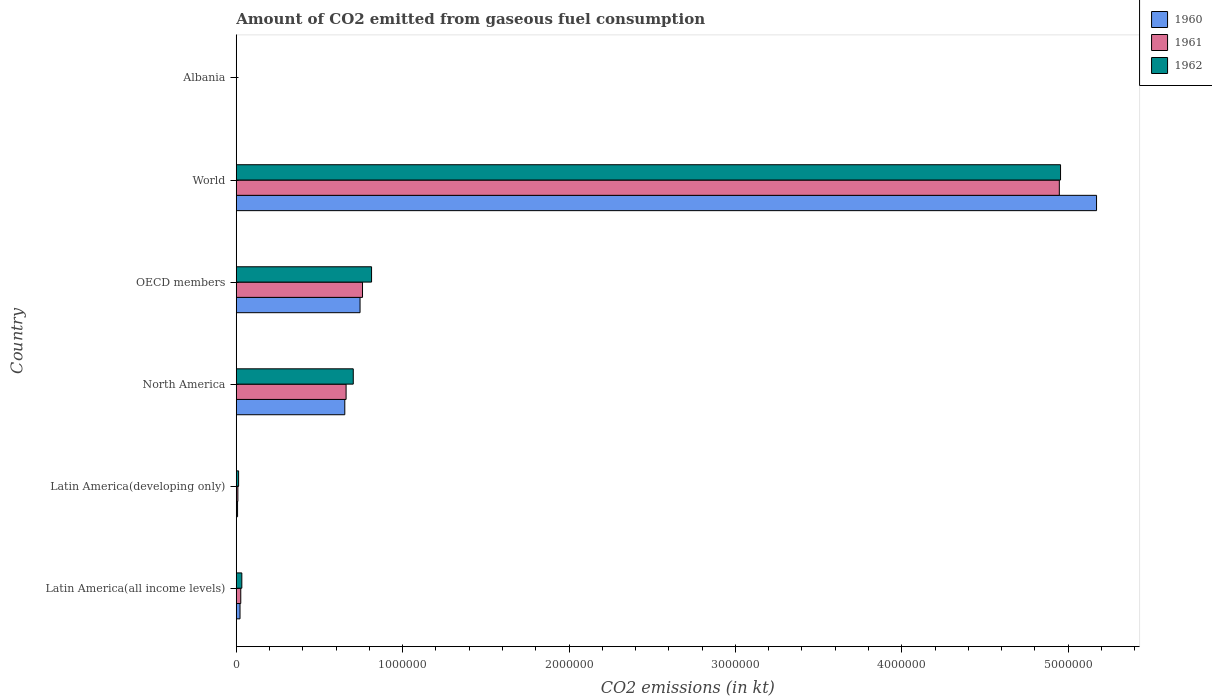How many different coloured bars are there?
Offer a very short reply. 3. How many bars are there on the 5th tick from the top?
Provide a succinct answer. 3. What is the label of the 6th group of bars from the top?
Make the answer very short. Latin America(all income levels). In how many cases, is the number of bars for a given country not equal to the number of legend labels?
Provide a short and direct response. 0. What is the amount of CO2 emitted in 1960 in World?
Give a very brief answer. 5.17e+06. Across all countries, what is the maximum amount of CO2 emitted in 1962?
Provide a short and direct response. 4.95e+06. Across all countries, what is the minimum amount of CO2 emitted in 1961?
Make the answer very short. 84.34. In which country was the amount of CO2 emitted in 1962 maximum?
Make the answer very short. World. In which country was the amount of CO2 emitted in 1961 minimum?
Keep it short and to the point. Albania. What is the total amount of CO2 emitted in 1961 in the graph?
Give a very brief answer. 6.40e+06. What is the difference between the amount of CO2 emitted in 1960 in Albania and that in Latin America(all income levels)?
Offer a terse response. -2.25e+04. What is the difference between the amount of CO2 emitted in 1961 in Albania and the amount of CO2 emitted in 1960 in OECD members?
Your response must be concise. -7.44e+05. What is the average amount of CO2 emitted in 1960 per country?
Offer a terse response. 1.10e+06. What is the difference between the amount of CO2 emitted in 1960 and amount of CO2 emitted in 1961 in OECD members?
Provide a short and direct response. -1.48e+04. What is the ratio of the amount of CO2 emitted in 1961 in Latin America(all income levels) to that in North America?
Give a very brief answer. 0.04. What is the difference between the highest and the second highest amount of CO2 emitted in 1960?
Offer a terse response. 4.43e+06. What is the difference between the highest and the lowest amount of CO2 emitted in 1961?
Offer a very short reply. 4.95e+06. In how many countries, is the amount of CO2 emitted in 1960 greater than the average amount of CO2 emitted in 1960 taken over all countries?
Ensure brevity in your answer.  1. Is the sum of the amount of CO2 emitted in 1962 in Latin America(all income levels) and World greater than the maximum amount of CO2 emitted in 1960 across all countries?
Provide a short and direct response. No. What does the 2nd bar from the top in OECD members represents?
Make the answer very short. 1961. What does the 3rd bar from the bottom in World represents?
Your response must be concise. 1962. How many bars are there?
Your answer should be compact. 18. Are all the bars in the graph horizontal?
Your response must be concise. Yes. Are the values on the major ticks of X-axis written in scientific E-notation?
Your answer should be very brief. No. Does the graph contain grids?
Your response must be concise. No. How many legend labels are there?
Keep it short and to the point. 3. How are the legend labels stacked?
Your answer should be compact. Vertical. What is the title of the graph?
Ensure brevity in your answer.  Amount of CO2 emitted from gaseous fuel consumption. Does "1987" appear as one of the legend labels in the graph?
Offer a very short reply. No. What is the label or title of the X-axis?
Offer a terse response. CO2 emissions (in kt). What is the label or title of the Y-axis?
Give a very brief answer. Country. What is the CO2 emissions (in kt) of 1960 in Latin America(all income levels)?
Your answer should be compact. 2.26e+04. What is the CO2 emissions (in kt) of 1961 in Latin America(all income levels)?
Your answer should be very brief. 2.71e+04. What is the CO2 emissions (in kt) of 1962 in Latin America(all income levels)?
Your response must be concise. 3.35e+04. What is the CO2 emissions (in kt) of 1960 in Latin America(developing only)?
Provide a succinct answer. 7838.55. What is the CO2 emissions (in kt) in 1961 in Latin America(developing only)?
Offer a terse response. 9714.77. What is the CO2 emissions (in kt) of 1962 in Latin America(developing only)?
Provide a short and direct response. 1.42e+04. What is the CO2 emissions (in kt) in 1960 in North America?
Offer a terse response. 6.52e+05. What is the CO2 emissions (in kt) in 1961 in North America?
Keep it short and to the point. 6.60e+05. What is the CO2 emissions (in kt) in 1962 in North America?
Provide a succinct answer. 7.03e+05. What is the CO2 emissions (in kt) in 1960 in OECD members?
Your response must be concise. 7.44e+05. What is the CO2 emissions (in kt) in 1961 in OECD members?
Offer a very short reply. 7.59e+05. What is the CO2 emissions (in kt) of 1962 in OECD members?
Your response must be concise. 8.13e+05. What is the CO2 emissions (in kt) in 1960 in World?
Offer a very short reply. 5.17e+06. What is the CO2 emissions (in kt) of 1961 in World?
Your answer should be very brief. 4.95e+06. What is the CO2 emissions (in kt) in 1962 in World?
Keep it short and to the point. 4.95e+06. What is the CO2 emissions (in kt) of 1960 in Albania?
Your answer should be very brief. 84.34. What is the CO2 emissions (in kt) in 1961 in Albania?
Offer a terse response. 84.34. What is the CO2 emissions (in kt) of 1962 in Albania?
Ensure brevity in your answer.  84.34. Across all countries, what is the maximum CO2 emissions (in kt) in 1960?
Provide a short and direct response. 5.17e+06. Across all countries, what is the maximum CO2 emissions (in kt) in 1961?
Your answer should be very brief. 4.95e+06. Across all countries, what is the maximum CO2 emissions (in kt) in 1962?
Offer a very short reply. 4.95e+06. Across all countries, what is the minimum CO2 emissions (in kt) of 1960?
Your answer should be very brief. 84.34. Across all countries, what is the minimum CO2 emissions (in kt) in 1961?
Offer a very short reply. 84.34. Across all countries, what is the minimum CO2 emissions (in kt) of 1962?
Give a very brief answer. 84.34. What is the total CO2 emissions (in kt) of 1960 in the graph?
Provide a succinct answer. 6.60e+06. What is the total CO2 emissions (in kt) of 1961 in the graph?
Ensure brevity in your answer.  6.40e+06. What is the total CO2 emissions (in kt) of 1962 in the graph?
Provide a short and direct response. 6.52e+06. What is the difference between the CO2 emissions (in kt) in 1960 in Latin America(all income levels) and that in Latin America(developing only)?
Keep it short and to the point. 1.47e+04. What is the difference between the CO2 emissions (in kt) in 1961 in Latin America(all income levels) and that in Latin America(developing only)?
Give a very brief answer. 1.74e+04. What is the difference between the CO2 emissions (in kt) of 1962 in Latin America(all income levels) and that in Latin America(developing only)?
Your response must be concise. 1.93e+04. What is the difference between the CO2 emissions (in kt) of 1960 in Latin America(all income levels) and that in North America?
Make the answer very short. -6.30e+05. What is the difference between the CO2 emissions (in kt) of 1961 in Latin America(all income levels) and that in North America?
Provide a short and direct response. -6.33e+05. What is the difference between the CO2 emissions (in kt) of 1962 in Latin America(all income levels) and that in North America?
Make the answer very short. -6.70e+05. What is the difference between the CO2 emissions (in kt) in 1960 in Latin America(all income levels) and that in OECD members?
Offer a terse response. -7.21e+05. What is the difference between the CO2 emissions (in kt) of 1961 in Latin America(all income levels) and that in OECD members?
Give a very brief answer. -7.32e+05. What is the difference between the CO2 emissions (in kt) of 1962 in Latin America(all income levels) and that in OECD members?
Give a very brief answer. -7.80e+05. What is the difference between the CO2 emissions (in kt) of 1960 in Latin America(all income levels) and that in World?
Make the answer very short. -5.15e+06. What is the difference between the CO2 emissions (in kt) of 1961 in Latin America(all income levels) and that in World?
Give a very brief answer. -4.92e+06. What is the difference between the CO2 emissions (in kt) of 1962 in Latin America(all income levels) and that in World?
Provide a succinct answer. -4.92e+06. What is the difference between the CO2 emissions (in kt) in 1960 in Latin America(all income levels) and that in Albania?
Your answer should be very brief. 2.25e+04. What is the difference between the CO2 emissions (in kt) of 1961 in Latin America(all income levels) and that in Albania?
Your answer should be compact. 2.70e+04. What is the difference between the CO2 emissions (in kt) in 1962 in Latin America(all income levels) and that in Albania?
Offer a terse response. 3.34e+04. What is the difference between the CO2 emissions (in kt) in 1960 in Latin America(developing only) and that in North America?
Provide a short and direct response. -6.45e+05. What is the difference between the CO2 emissions (in kt) in 1961 in Latin America(developing only) and that in North America?
Provide a short and direct response. -6.50e+05. What is the difference between the CO2 emissions (in kt) in 1962 in Latin America(developing only) and that in North America?
Offer a terse response. -6.89e+05. What is the difference between the CO2 emissions (in kt) of 1960 in Latin America(developing only) and that in OECD members?
Provide a succinct answer. -7.36e+05. What is the difference between the CO2 emissions (in kt) of 1961 in Latin America(developing only) and that in OECD members?
Your answer should be very brief. -7.49e+05. What is the difference between the CO2 emissions (in kt) in 1962 in Latin America(developing only) and that in OECD members?
Your response must be concise. -7.99e+05. What is the difference between the CO2 emissions (in kt) of 1960 in Latin America(developing only) and that in World?
Give a very brief answer. -5.16e+06. What is the difference between the CO2 emissions (in kt) in 1961 in Latin America(developing only) and that in World?
Provide a short and direct response. -4.94e+06. What is the difference between the CO2 emissions (in kt) in 1962 in Latin America(developing only) and that in World?
Make the answer very short. -4.94e+06. What is the difference between the CO2 emissions (in kt) of 1960 in Latin America(developing only) and that in Albania?
Keep it short and to the point. 7754.21. What is the difference between the CO2 emissions (in kt) in 1961 in Latin America(developing only) and that in Albania?
Your answer should be very brief. 9630.43. What is the difference between the CO2 emissions (in kt) in 1962 in Latin America(developing only) and that in Albania?
Your response must be concise. 1.41e+04. What is the difference between the CO2 emissions (in kt) of 1960 in North America and that in OECD members?
Offer a very short reply. -9.17e+04. What is the difference between the CO2 emissions (in kt) in 1961 in North America and that in OECD members?
Offer a terse response. -9.86e+04. What is the difference between the CO2 emissions (in kt) of 1962 in North America and that in OECD members?
Your answer should be very brief. -1.10e+05. What is the difference between the CO2 emissions (in kt) of 1960 in North America and that in World?
Ensure brevity in your answer.  -4.52e+06. What is the difference between the CO2 emissions (in kt) in 1961 in North America and that in World?
Keep it short and to the point. -4.29e+06. What is the difference between the CO2 emissions (in kt) of 1962 in North America and that in World?
Offer a very short reply. -4.25e+06. What is the difference between the CO2 emissions (in kt) in 1960 in North America and that in Albania?
Make the answer very short. 6.52e+05. What is the difference between the CO2 emissions (in kt) of 1961 in North America and that in Albania?
Offer a terse response. 6.60e+05. What is the difference between the CO2 emissions (in kt) in 1962 in North America and that in Albania?
Make the answer very short. 7.03e+05. What is the difference between the CO2 emissions (in kt) in 1960 in OECD members and that in World?
Provide a short and direct response. -4.43e+06. What is the difference between the CO2 emissions (in kt) of 1961 in OECD members and that in World?
Make the answer very short. -4.19e+06. What is the difference between the CO2 emissions (in kt) in 1962 in OECD members and that in World?
Ensure brevity in your answer.  -4.14e+06. What is the difference between the CO2 emissions (in kt) of 1960 in OECD members and that in Albania?
Your answer should be compact. 7.44e+05. What is the difference between the CO2 emissions (in kt) of 1961 in OECD members and that in Albania?
Your answer should be compact. 7.59e+05. What is the difference between the CO2 emissions (in kt) in 1962 in OECD members and that in Albania?
Your response must be concise. 8.13e+05. What is the difference between the CO2 emissions (in kt) of 1960 in World and that in Albania?
Provide a short and direct response. 5.17e+06. What is the difference between the CO2 emissions (in kt) in 1961 in World and that in Albania?
Keep it short and to the point. 4.95e+06. What is the difference between the CO2 emissions (in kt) of 1962 in World and that in Albania?
Your answer should be compact. 4.95e+06. What is the difference between the CO2 emissions (in kt) in 1960 in Latin America(all income levels) and the CO2 emissions (in kt) in 1961 in Latin America(developing only)?
Offer a very short reply. 1.29e+04. What is the difference between the CO2 emissions (in kt) of 1960 in Latin America(all income levels) and the CO2 emissions (in kt) of 1962 in Latin America(developing only)?
Give a very brief answer. 8397.37. What is the difference between the CO2 emissions (in kt) in 1961 in Latin America(all income levels) and the CO2 emissions (in kt) in 1962 in Latin America(developing only)?
Make the answer very short. 1.29e+04. What is the difference between the CO2 emissions (in kt) in 1960 in Latin America(all income levels) and the CO2 emissions (in kt) in 1961 in North America?
Ensure brevity in your answer.  -6.38e+05. What is the difference between the CO2 emissions (in kt) in 1960 in Latin America(all income levels) and the CO2 emissions (in kt) in 1962 in North America?
Ensure brevity in your answer.  -6.81e+05. What is the difference between the CO2 emissions (in kt) of 1961 in Latin America(all income levels) and the CO2 emissions (in kt) of 1962 in North America?
Your response must be concise. -6.76e+05. What is the difference between the CO2 emissions (in kt) in 1960 in Latin America(all income levels) and the CO2 emissions (in kt) in 1961 in OECD members?
Provide a succinct answer. -7.36e+05. What is the difference between the CO2 emissions (in kt) of 1960 in Latin America(all income levels) and the CO2 emissions (in kt) of 1962 in OECD members?
Ensure brevity in your answer.  -7.91e+05. What is the difference between the CO2 emissions (in kt) of 1961 in Latin America(all income levels) and the CO2 emissions (in kt) of 1962 in OECD members?
Your response must be concise. -7.86e+05. What is the difference between the CO2 emissions (in kt) in 1960 in Latin America(all income levels) and the CO2 emissions (in kt) in 1961 in World?
Provide a short and direct response. -4.92e+06. What is the difference between the CO2 emissions (in kt) of 1960 in Latin America(all income levels) and the CO2 emissions (in kt) of 1962 in World?
Give a very brief answer. -4.93e+06. What is the difference between the CO2 emissions (in kt) of 1961 in Latin America(all income levels) and the CO2 emissions (in kt) of 1962 in World?
Give a very brief answer. -4.93e+06. What is the difference between the CO2 emissions (in kt) of 1960 in Latin America(all income levels) and the CO2 emissions (in kt) of 1961 in Albania?
Offer a very short reply. 2.25e+04. What is the difference between the CO2 emissions (in kt) of 1960 in Latin America(all income levels) and the CO2 emissions (in kt) of 1962 in Albania?
Provide a short and direct response. 2.25e+04. What is the difference between the CO2 emissions (in kt) in 1961 in Latin America(all income levels) and the CO2 emissions (in kt) in 1962 in Albania?
Provide a short and direct response. 2.70e+04. What is the difference between the CO2 emissions (in kt) of 1960 in Latin America(developing only) and the CO2 emissions (in kt) of 1961 in North America?
Provide a succinct answer. -6.52e+05. What is the difference between the CO2 emissions (in kt) of 1960 in Latin America(developing only) and the CO2 emissions (in kt) of 1962 in North America?
Keep it short and to the point. -6.95e+05. What is the difference between the CO2 emissions (in kt) of 1961 in Latin America(developing only) and the CO2 emissions (in kt) of 1962 in North America?
Provide a succinct answer. -6.93e+05. What is the difference between the CO2 emissions (in kt) in 1960 in Latin America(developing only) and the CO2 emissions (in kt) in 1961 in OECD members?
Make the answer very short. -7.51e+05. What is the difference between the CO2 emissions (in kt) in 1960 in Latin America(developing only) and the CO2 emissions (in kt) in 1962 in OECD members?
Give a very brief answer. -8.05e+05. What is the difference between the CO2 emissions (in kt) of 1961 in Latin America(developing only) and the CO2 emissions (in kt) of 1962 in OECD members?
Give a very brief answer. -8.03e+05. What is the difference between the CO2 emissions (in kt) in 1960 in Latin America(developing only) and the CO2 emissions (in kt) in 1961 in World?
Your answer should be very brief. -4.94e+06. What is the difference between the CO2 emissions (in kt) of 1960 in Latin America(developing only) and the CO2 emissions (in kt) of 1962 in World?
Provide a succinct answer. -4.95e+06. What is the difference between the CO2 emissions (in kt) in 1961 in Latin America(developing only) and the CO2 emissions (in kt) in 1962 in World?
Make the answer very short. -4.94e+06. What is the difference between the CO2 emissions (in kt) of 1960 in Latin America(developing only) and the CO2 emissions (in kt) of 1961 in Albania?
Your answer should be compact. 7754.21. What is the difference between the CO2 emissions (in kt) of 1960 in Latin America(developing only) and the CO2 emissions (in kt) of 1962 in Albania?
Give a very brief answer. 7754.21. What is the difference between the CO2 emissions (in kt) of 1961 in Latin America(developing only) and the CO2 emissions (in kt) of 1962 in Albania?
Make the answer very short. 9630.43. What is the difference between the CO2 emissions (in kt) of 1960 in North America and the CO2 emissions (in kt) of 1961 in OECD members?
Give a very brief answer. -1.06e+05. What is the difference between the CO2 emissions (in kt) in 1960 in North America and the CO2 emissions (in kt) in 1962 in OECD members?
Provide a succinct answer. -1.61e+05. What is the difference between the CO2 emissions (in kt) of 1961 in North America and the CO2 emissions (in kt) of 1962 in OECD members?
Your response must be concise. -1.53e+05. What is the difference between the CO2 emissions (in kt) in 1960 in North America and the CO2 emissions (in kt) in 1961 in World?
Provide a succinct answer. -4.29e+06. What is the difference between the CO2 emissions (in kt) of 1960 in North America and the CO2 emissions (in kt) of 1962 in World?
Your answer should be very brief. -4.30e+06. What is the difference between the CO2 emissions (in kt) of 1961 in North America and the CO2 emissions (in kt) of 1962 in World?
Provide a succinct answer. -4.29e+06. What is the difference between the CO2 emissions (in kt) of 1960 in North America and the CO2 emissions (in kt) of 1961 in Albania?
Give a very brief answer. 6.52e+05. What is the difference between the CO2 emissions (in kt) of 1960 in North America and the CO2 emissions (in kt) of 1962 in Albania?
Ensure brevity in your answer.  6.52e+05. What is the difference between the CO2 emissions (in kt) in 1961 in North America and the CO2 emissions (in kt) in 1962 in Albania?
Your response must be concise. 6.60e+05. What is the difference between the CO2 emissions (in kt) in 1960 in OECD members and the CO2 emissions (in kt) in 1961 in World?
Offer a terse response. -4.20e+06. What is the difference between the CO2 emissions (in kt) in 1960 in OECD members and the CO2 emissions (in kt) in 1962 in World?
Your answer should be compact. -4.21e+06. What is the difference between the CO2 emissions (in kt) of 1961 in OECD members and the CO2 emissions (in kt) of 1962 in World?
Offer a very short reply. -4.20e+06. What is the difference between the CO2 emissions (in kt) in 1960 in OECD members and the CO2 emissions (in kt) in 1961 in Albania?
Offer a terse response. 7.44e+05. What is the difference between the CO2 emissions (in kt) in 1960 in OECD members and the CO2 emissions (in kt) in 1962 in Albania?
Your answer should be compact. 7.44e+05. What is the difference between the CO2 emissions (in kt) in 1961 in OECD members and the CO2 emissions (in kt) in 1962 in Albania?
Provide a short and direct response. 7.59e+05. What is the difference between the CO2 emissions (in kt) of 1960 in World and the CO2 emissions (in kt) of 1961 in Albania?
Provide a short and direct response. 5.17e+06. What is the difference between the CO2 emissions (in kt) of 1960 in World and the CO2 emissions (in kt) of 1962 in Albania?
Give a very brief answer. 5.17e+06. What is the difference between the CO2 emissions (in kt) in 1961 in World and the CO2 emissions (in kt) in 1962 in Albania?
Your response must be concise. 4.95e+06. What is the average CO2 emissions (in kt) in 1960 per country?
Offer a very short reply. 1.10e+06. What is the average CO2 emissions (in kt) of 1961 per country?
Give a very brief answer. 1.07e+06. What is the average CO2 emissions (in kt) of 1962 per country?
Your answer should be very brief. 1.09e+06. What is the difference between the CO2 emissions (in kt) of 1960 and CO2 emissions (in kt) of 1961 in Latin America(all income levels)?
Your response must be concise. -4542.92. What is the difference between the CO2 emissions (in kt) of 1960 and CO2 emissions (in kt) of 1962 in Latin America(all income levels)?
Ensure brevity in your answer.  -1.09e+04. What is the difference between the CO2 emissions (in kt) of 1961 and CO2 emissions (in kt) of 1962 in Latin America(all income levels)?
Make the answer very short. -6377.63. What is the difference between the CO2 emissions (in kt) of 1960 and CO2 emissions (in kt) of 1961 in Latin America(developing only)?
Your answer should be very brief. -1876.23. What is the difference between the CO2 emissions (in kt) in 1960 and CO2 emissions (in kt) in 1962 in Latin America(developing only)?
Offer a very short reply. -6343.06. What is the difference between the CO2 emissions (in kt) of 1961 and CO2 emissions (in kt) of 1962 in Latin America(developing only)?
Provide a succinct answer. -4466.83. What is the difference between the CO2 emissions (in kt) of 1960 and CO2 emissions (in kt) of 1961 in North America?
Provide a succinct answer. -7828.66. What is the difference between the CO2 emissions (in kt) of 1960 and CO2 emissions (in kt) of 1962 in North America?
Ensure brevity in your answer.  -5.08e+04. What is the difference between the CO2 emissions (in kt) of 1961 and CO2 emissions (in kt) of 1962 in North America?
Provide a succinct answer. -4.30e+04. What is the difference between the CO2 emissions (in kt) of 1960 and CO2 emissions (in kt) of 1961 in OECD members?
Your response must be concise. -1.48e+04. What is the difference between the CO2 emissions (in kt) in 1960 and CO2 emissions (in kt) in 1962 in OECD members?
Provide a succinct answer. -6.92e+04. What is the difference between the CO2 emissions (in kt) in 1961 and CO2 emissions (in kt) in 1962 in OECD members?
Make the answer very short. -5.44e+04. What is the difference between the CO2 emissions (in kt) in 1960 and CO2 emissions (in kt) in 1961 in World?
Your answer should be very brief. 2.24e+05. What is the difference between the CO2 emissions (in kt) of 1960 and CO2 emissions (in kt) of 1962 in World?
Ensure brevity in your answer.  2.16e+05. What is the difference between the CO2 emissions (in kt) of 1961 and CO2 emissions (in kt) of 1962 in World?
Keep it short and to the point. -7334. What is the difference between the CO2 emissions (in kt) of 1960 and CO2 emissions (in kt) of 1962 in Albania?
Ensure brevity in your answer.  0. What is the difference between the CO2 emissions (in kt) of 1961 and CO2 emissions (in kt) of 1962 in Albania?
Provide a short and direct response. 0. What is the ratio of the CO2 emissions (in kt) in 1960 in Latin America(all income levels) to that in Latin America(developing only)?
Provide a succinct answer. 2.88. What is the ratio of the CO2 emissions (in kt) of 1961 in Latin America(all income levels) to that in Latin America(developing only)?
Offer a terse response. 2.79. What is the ratio of the CO2 emissions (in kt) of 1962 in Latin America(all income levels) to that in Latin America(developing only)?
Make the answer very short. 2.36. What is the ratio of the CO2 emissions (in kt) in 1960 in Latin America(all income levels) to that in North America?
Keep it short and to the point. 0.03. What is the ratio of the CO2 emissions (in kt) of 1961 in Latin America(all income levels) to that in North America?
Provide a succinct answer. 0.04. What is the ratio of the CO2 emissions (in kt) of 1962 in Latin America(all income levels) to that in North America?
Offer a very short reply. 0.05. What is the ratio of the CO2 emissions (in kt) in 1960 in Latin America(all income levels) to that in OECD members?
Offer a terse response. 0.03. What is the ratio of the CO2 emissions (in kt) of 1961 in Latin America(all income levels) to that in OECD members?
Your response must be concise. 0.04. What is the ratio of the CO2 emissions (in kt) of 1962 in Latin America(all income levels) to that in OECD members?
Your response must be concise. 0.04. What is the ratio of the CO2 emissions (in kt) of 1960 in Latin America(all income levels) to that in World?
Provide a succinct answer. 0. What is the ratio of the CO2 emissions (in kt) of 1961 in Latin America(all income levels) to that in World?
Give a very brief answer. 0.01. What is the ratio of the CO2 emissions (in kt) in 1962 in Latin America(all income levels) to that in World?
Provide a succinct answer. 0.01. What is the ratio of the CO2 emissions (in kt) of 1960 in Latin America(all income levels) to that in Albania?
Make the answer very short. 267.71. What is the ratio of the CO2 emissions (in kt) of 1961 in Latin America(all income levels) to that in Albania?
Offer a very short reply. 321.57. What is the ratio of the CO2 emissions (in kt) of 1962 in Latin America(all income levels) to that in Albania?
Your answer should be very brief. 397.19. What is the ratio of the CO2 emissions (in kt) in 1960 in Latin America(developing only) to that in North America?
Provide a succinct answer. 0.01. What is the ratio of the CO2 emissions (in kt) in 1961 in Latin America(developing only) to that in North America?
Your answer should be compact. 0.01. What is the ratio of the CO2 emissions (in kt) in 1962 in Latin America(developing only) to that in North America?
Provide a short and direct response. 0.02. What is the ratio of the CO2 emissions (in kt) in 1960 in Latin America(developing only) to that in OECD members?
Offer a terse response. 0.01. What is the ratio of the CO2 emissions (in kt) of 1961 in Latin America(developing only) to that in OECD members?
Your response must be concise. 0.01. What is the ratio of the CO2 emissions (in kt) of 1962 in Latin America(developing only) to that in OECD members?
Give a very brief answer. 0.02. What is the ratio of the CO2 emissions (in kt) in 1960 in Latin America(developing only) to that in World?
Give a very brief answer. 0. What is the ratio of the CO2 emissions (in kt) in 1961 in Latin America(developing only) to that in World?
Your response must be concise. 0. What is the ratio of the CO2 emissions (in kt) in 1962 in Latin America(developing only) to that in World?
Provide a short and direct response. 0. What is the ratio of the CO2 emissions (in kt) of 1960 in Latin America(developing only) to that in Albania?
Keep it short and to the point. 92.94. What is the ratio of the CO2 emissions (in kt) in 1961 in Latin America(developing only) to that in Albania?
Ensure brevity in your answer.  115.18. What is the ratio of the CO2 emissions (in kt) in 1962 in Latin America(developing only) to that in Albania?
Offer a terse response. 168.15. What is the ratio of the CO2 emissions (in kt) of 1960 in North America to that in OECD members?
Ensure brevity in your answer.  0.88. What is the ratio of the CO2 emissions (in kt) of 1961 in North America to that in OECD members?
Your response must be concise. 0.87. What is the ratio of the CO2 emissions (in kt) in 1962 in North America to that in OECD members?
Ensure brevity in your answer.  0.86. What is the ratio of the CO2 emissions (in kt) of 1960 in North America to that in World?
Offer a very short reply. 0.13. What is the ratio of the CO2 emissions (in kt) of 1961 in North America to that in World?
Offer a very short reply. 0.13. What is the ratio of the CO2 emissions (in kt) in 1962 in North America to that in World?
Your answer should be compact. 0.14. What is the ratio of the CO2 emissions (in kt) of 1960 in North America to that in Albania?
Make the answer very short. 7734.89. What is the ratio of the CO2 emissions (in kt) in 1961 in North America to that in Albania?
Give a very brief answer. 7827.72. What is the ratio of the CO2 emissions (in kt) in 1962 in North America to that in Albania?
Give a very brief answer. 8337.76. What is the ratio of the CO2 emissions (in kt) of 1960 in OECD members to that in World?
Give a very brief answer. 0.14. What is the ratio of the CO2 emissions (in kt) of 1961 in OECD members to that in World?
Your answer should be compact. 0.15. What is the ratio of the CO2 emissions (in kt) of 1962 in OECD members to that in World?
Keep it short and to the point. 0.16. What is the ratio of the CO2 emissions (in kt) of 1960 in OECD members to that in Albania?
Offer a very short reply. 8821.78. What is the ratio of the CO2 emissions (in kt) in 1961 in OECD members to that in Albania?
Give a very brief answer. 8997.23. What is the ratio of the CO2 emissions (in kt) in 1962 in OECD members to that in Albania?
Offer a terse response. 9641.88. What is the ratio of the CO2 emissions (in kt) in 1960 in World to that in Albania?
Make the answer very short. 6.13e+04. What is the ratio of the CO2 emissions (in kt) of 1961 in World to that in Albania?
Your answer should be compact. 5.87e+04. What is the ratio of the CO2 emissions (in kt) of 1962 in World to that in Albania?
Give a very brief answer. 5.87e+04. What is the difference between the highest and the second highest CO2 emissions (in kt) in 1960?
Your answer should be very brief. 4.43e+06. What is the difference between the highest and the second highest CO2 emissions (in kt) in 1961?
Your answer should be very brief. 4.19e+06. What is the difference between the highest and the second highest CO2 emissions (in kt) of 1962?
Make the answer very short. 4.14e+06. What is the difference between the highest and the lowest CO2 emissions (in kt) of 1960?
Keep it short and to the point. 5.17e+06. What is the difference between the highest and the lowest CO2 emissions (in kt) of 1961?
Provide a short and direct response. 4.95e+06. What is the difference between the highest and the lowest CO2 emissions (in kt) of 1962?
Your answer should be very brief. 4.95e+06. 